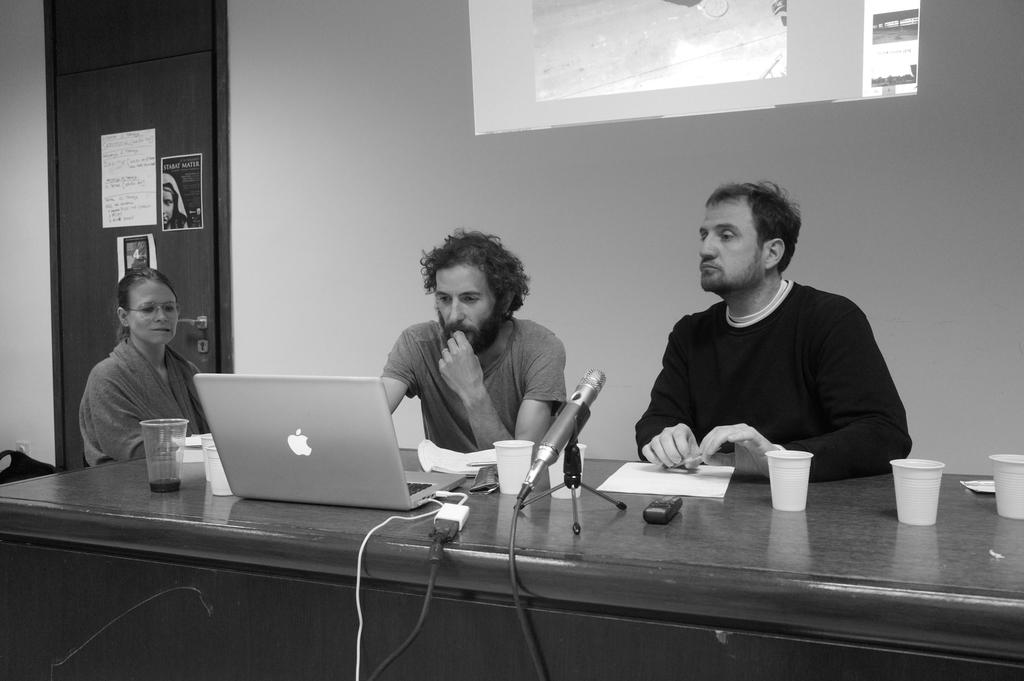What are the people in the image doing? The people in the image are sitting on chairs. What electronic device is on the table? There is a laptop on the table. What is the purpose of the mic with a stand on the table? The mic with a stand on the table is likely used for recording or amplifying sound. What type of items can be seen on the table besides the laptop and mic? There are papers and a glass on the table. What is the color scheme of the image? The image is in black and white color. What type of cake is being served during the recess in the image? There is no recess or cake present in the image. What is the zinc content of the glass on the table? The zinc content of the glass cannot be determined from the image, as it is not relevant to the contents of the glass. 